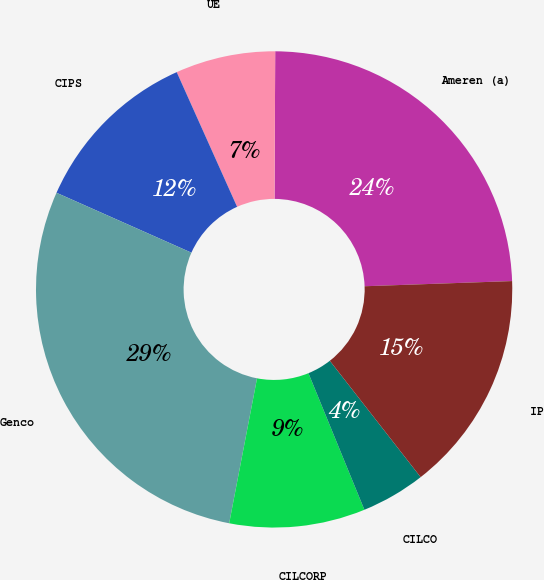Convert chart. <chart><loc_0><loc_0><loc_500><loc_500><pie_chart><fcel>Ameren (a)<fcel>UE<fcel>CIPS<fcel>Genco<fcel>CILCORP<fcel>CILCO<fcel>IP<nl><fcel>24.37%<fcel>6.78%<fcel>11.64%<fcel>28.63%<fcel>9.21%<fcel>4.36%<fcel>15.01%<nl></chart> 